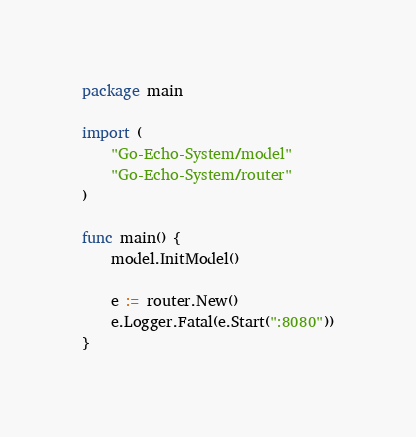Convert code to text. <code><loc_0><loc_0><loc_500><loc_500><_Go_>package main

import (
	"Go-Echo-System/model"
	"Go-Echo-System/router"
)

func main() {
	model.InitModel()

	e := router.New()
	e.Logger.Fatal(e.Start(":8080"))
}
</code> 